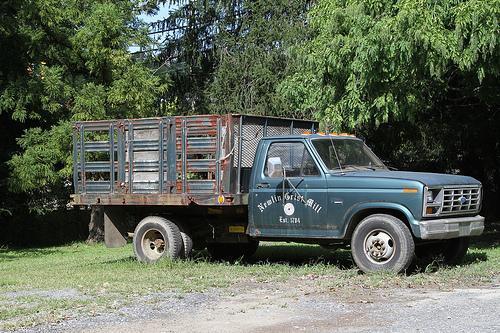How many vehicles are pictured?
Give a very brief answer. 1. 